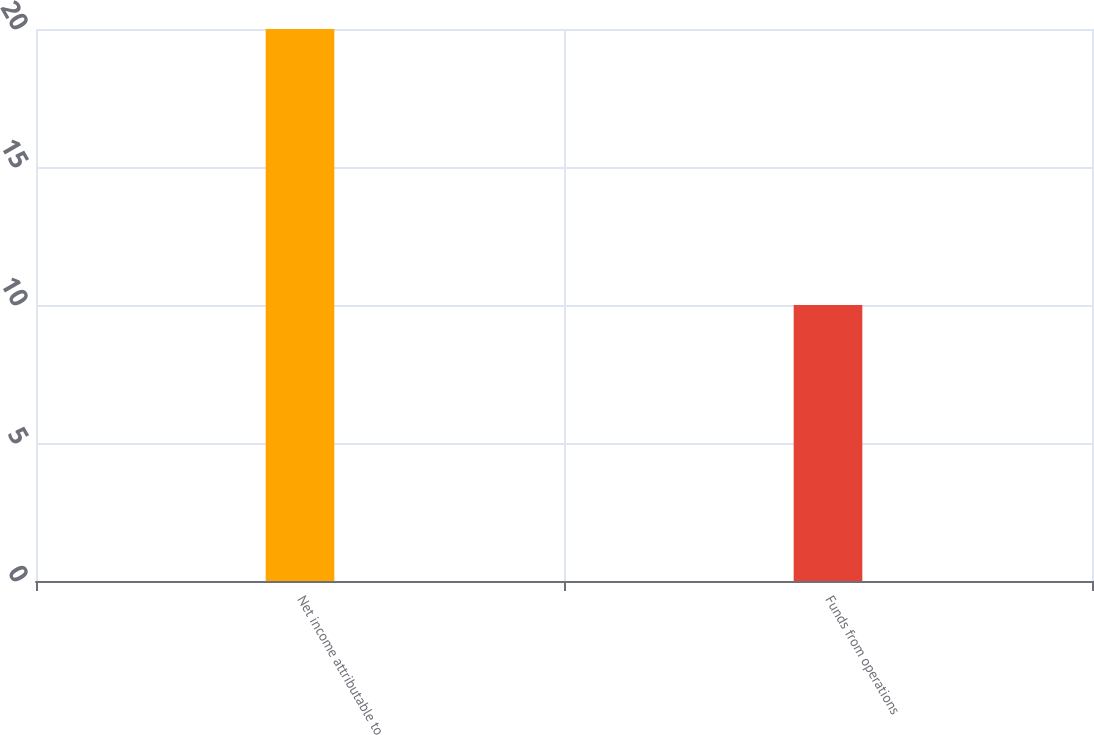Convert chart to OTSL. <chart><loc_0><loc_0><loc_500><loc_500><bar_chart><fcel>Net income attributable to<fcel>Funds from operations<nl><fcel>20<fcel>10<nl></chart> 